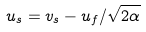<formula> <loc_0><loc_0><loc_500><loc_500>u _ { s } = v _ { s } - u _ { f } / \sqrt { 2 \alpha }</formula> 